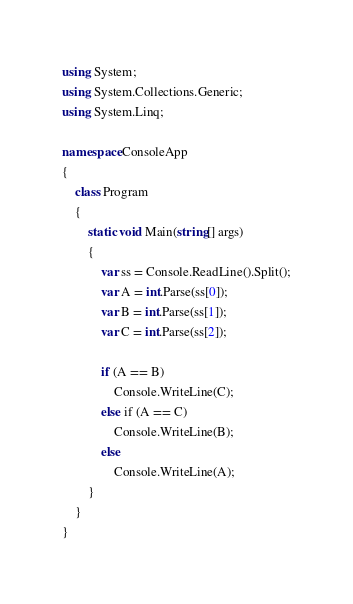<code> <loc_0><loc_0><loc_500><loc_500><_C#_>using System;
using System.Collections.Generic;
using System.Linq;

namespace ConsoleApp
{
    class Program
    {
        static void Main(string[] args)
        {
            var ss = Console.ReadLine().Split();
            var A = int.Parse(ss[0]);
            var B = int.Parse(ss[1]);
            var C = int.Parse(ss[2]);

            if (A == B)
                Console.WriteLine(C);
            else if (A == C)
                Console.WriteLine(B);
            else
                Console.WriteLine(A);
        }
    }
}</code> 